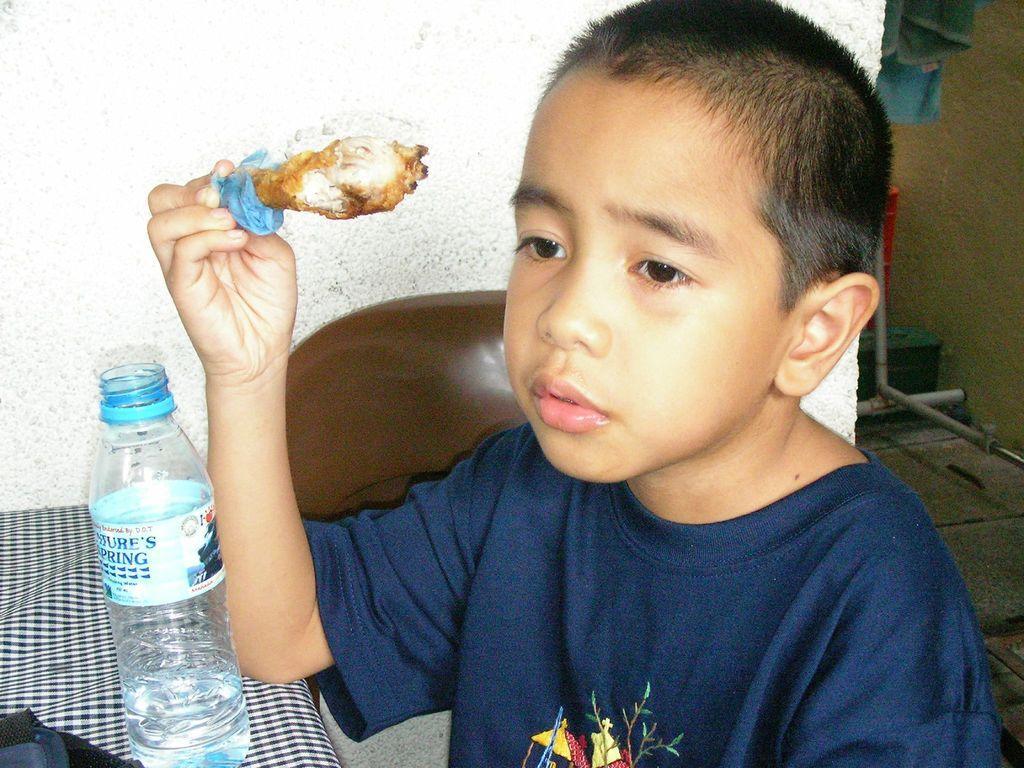In one or two sentences, can you explain what this image depicts? There is a boy holding a chicken leg piece. In front of him there is a table with check tablecloth. On the table there is a bottle. In the back there is a white wall. Also there are some pipes in the background. 